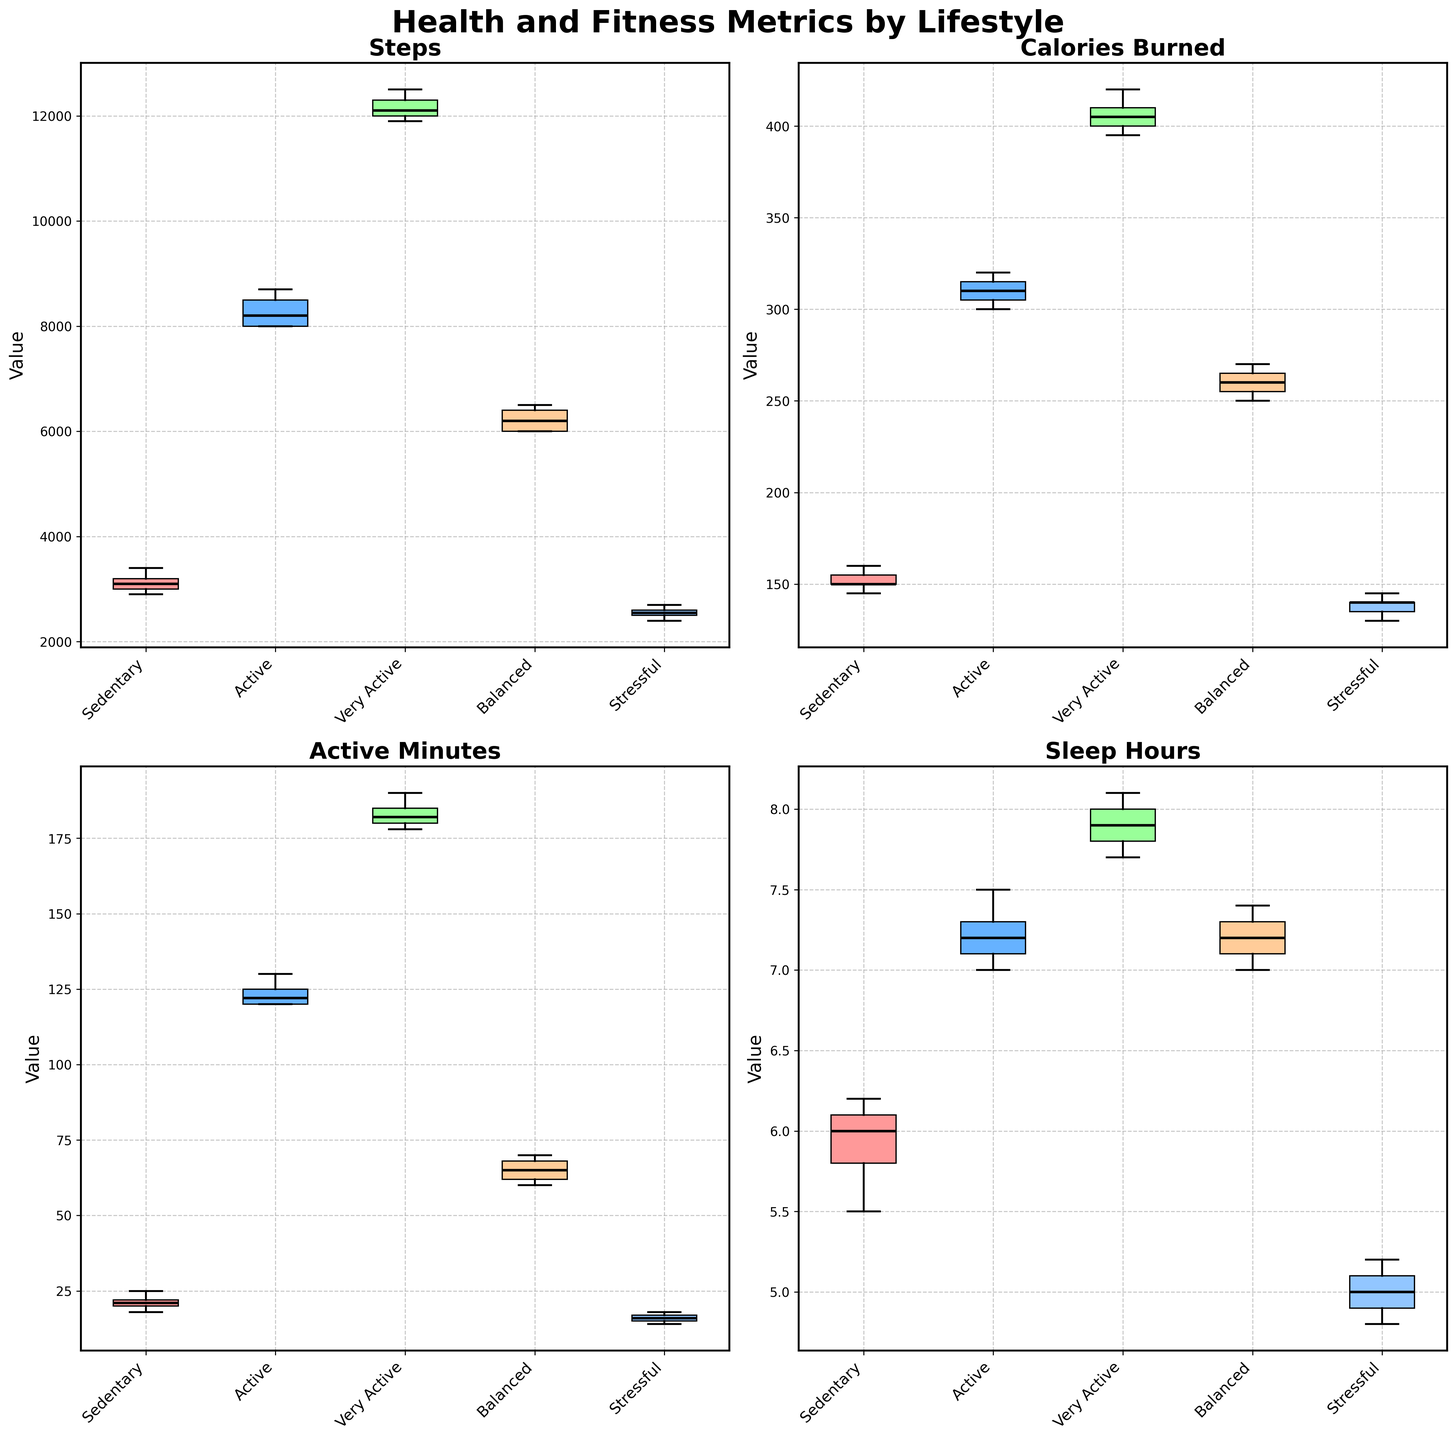What are the titles of the subplots? The subplots show metrics: 'Steps', 'Calories Burned', 'Active Minutes', and 'Sleep Hours'. Each title summarizes the data represented in the corresponding box plot.
Answer: Steps, Calories Burned, Active Minutes, Sleep Hours What lifestyle choice shows the highest median value for Steps? The box plot for 'Steps' has its highest median value in the 'Very Active' group, as indicated by the black median line in that group's box.
Answer: Very Active Which group has the smallest variation in Sleep Hours? The box plot for 'Sleep Hours' has the smallest interquartile range (IQR) in the 'Balanced' group, indicating less spread in the data. This is seen as the distance between the bottom and top of the box for 'Balanced' being smaller than the others.
Answer: Balanced Among all groups, which metric shows the greatest overall spread across all lifestyles? The box plot for 'Active Minutes' has the longest whiskers and widest boxes, indicating a greater spread or variation within 'Active Minutes' across all lifestyle choices.
Answer: Active Minutes Compare the median Calories Burned between Sedentary and Very Active lifestyles. Which is higher and by how much? The median for 'Calories Burned' in 'Very Active' is significantly higher than in 'Sedentary'. The black median line in 'Very Active' is at 410 and in 'Sedentary' it is at 150. The difference is 410 - 150 = 260.
Answer: Very Active by 260 Which lifestyle choice has the lowest minimum value for Steps? In the 'Steps' box plot, the 'Sedentary' lifestyle shows the lowest minimum value, indicated by the bottom whisker extending lower than those of the other groups.
Answer: Sedentary What is the approximate interquartile range (IQR) for Active Minutes in the Active group? The IQR is calculated by finding the difference between Q3 and Q1. For 'Active Minutes' in the 'Active' lifestyle, the upper quartile is approximately at 130, and the lower quartile is at 120. Therefore, IQR = 130 - 120 = 10.
Answer: 10 Which lifestyle has the highest median Sleep Hours, and what is its value? The box plot for 'Sleep Hours' shows that the 'Very Active' group has the highest median, with the black median line being at 7.8 hours.
Answer: Very Active, 7.8 How does the variation in Calories Burned compare between the Sedentary and Stressful lifestyles? The box plot for 'Calories Burned' shows a wider IQR and whiskers for the 'Sedentary' lifestyle compared to the 'Stressful' lifestyle, indicating greater variation in 'Sedentary'.
Answer: Greater in Sedentary Which lifestyle has a higher maximum value for Active Minutes, and what is this value? The 'Very Active' lifestyle has the highest maximum value for 'Active Minutes,' as indicated by the top whisker extending to 190 minutes.
Answer: Very Active, 190 